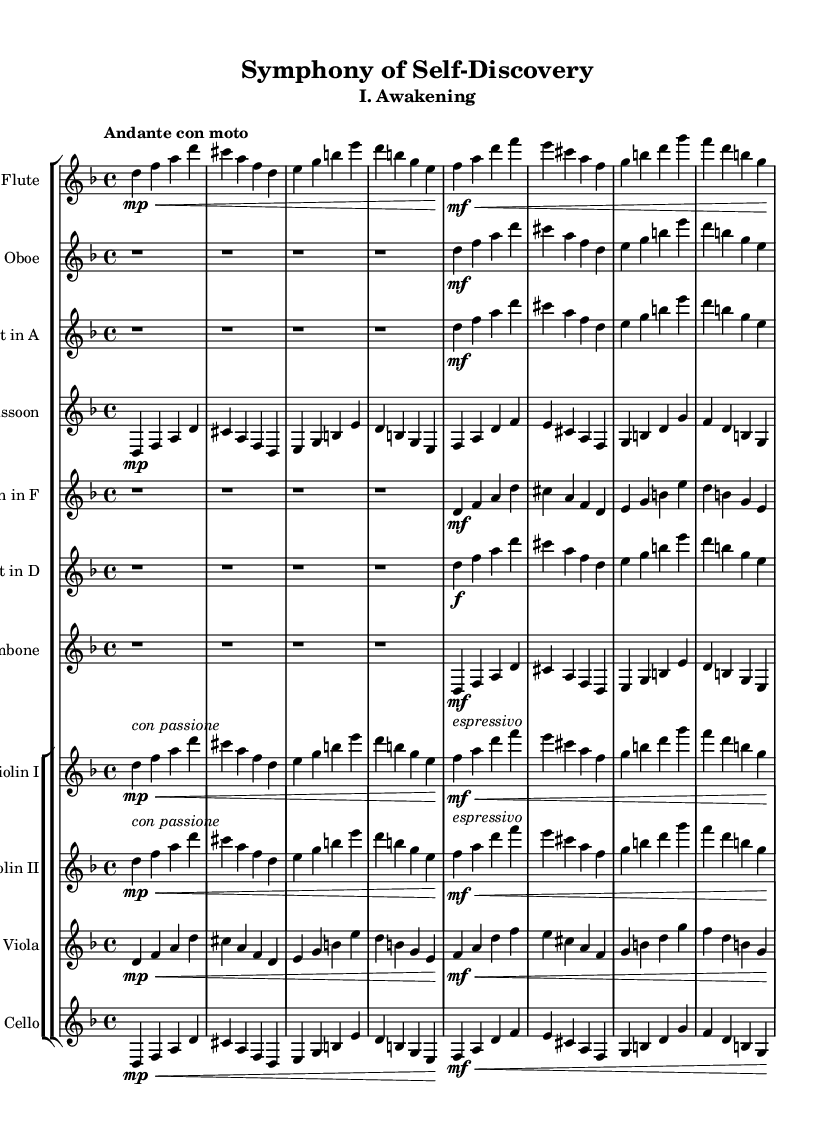What is the key signature of this symphony? The key signature is D minor, which has one flat (B flat) according to the global settings.
Answer: D minor What is the time signature of this piece? The time signature is 4/4, indicating four beats per measure with a quarter note receiving one beat.
Answer: 4/4 What is the tempo marking of the first movement? The tempo marking is "Andante con moto," which suggests a moderate pace with a bit of movement.
Answer: Andante con moto Which section first features the flute? The flute is first featured in the beginning of the piece, especially in measures 1-4, where it plays a primary melodic role.
Answer: Measures 1-4 How many instruments are in the orchestra for this piece? There are 12 staves in total for the ensemble, indicating 12 instruments in this orchestral arrangement.
Answer: 12 What dynamic instruction is given to the second section for the violin? The second section for the violin indicates a dynamic marking of "mf" with a text instruction "espressivo," suggesting a medium loud dynamic played expressively.
Answer: mf In which measure does the clarinet first play? The clarinet first plays in measure 5, where it joins the melody along with other woodwinds.
Answer: Measure 5 